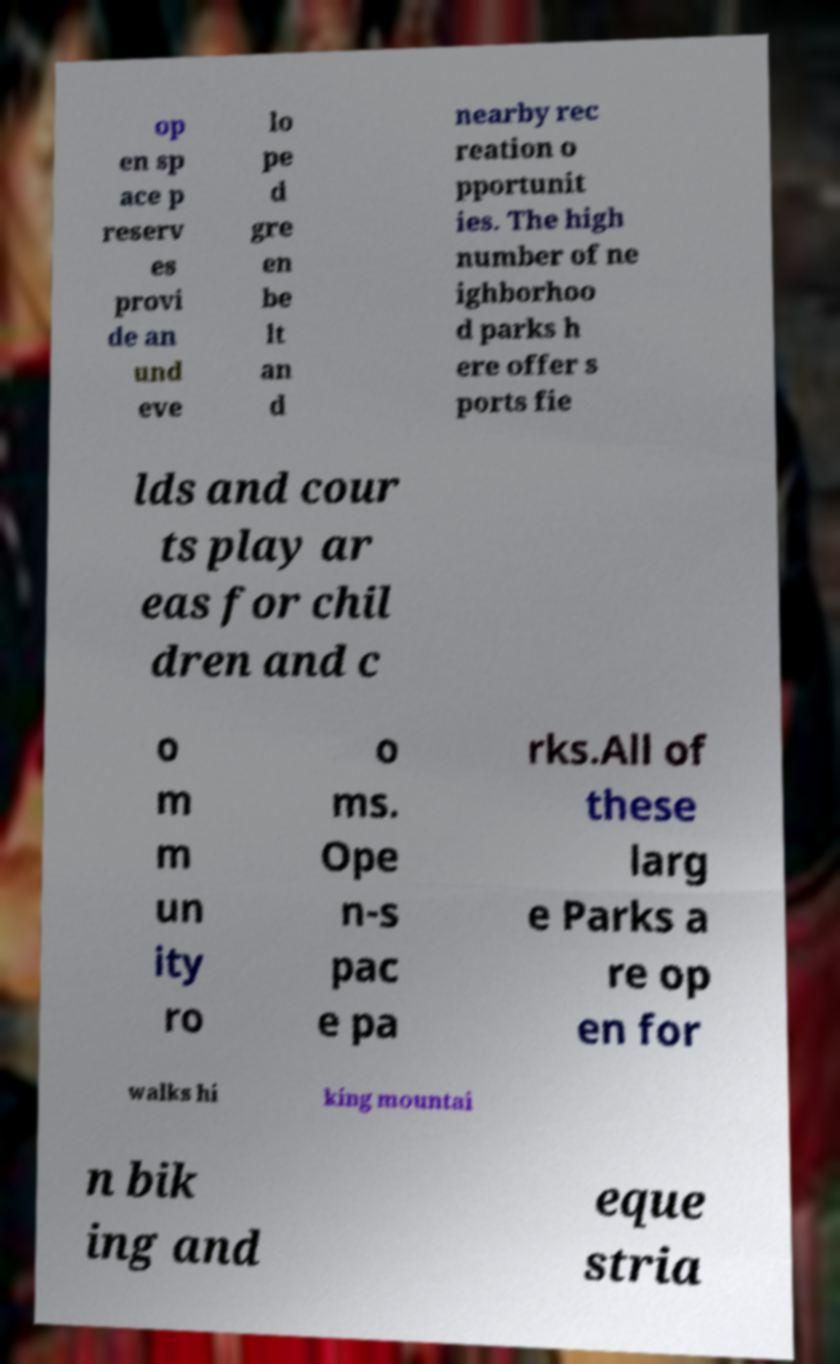Please read and relay the text visible in this image. What does it say? op en sp ace p reserv es provi de an und eve lo pe d gre en be lt an d nearby rec reation o pportunit ies. The high number of ne ighborhoo d parks h ere offer s ports fie lds and cour ts play ar eas for chil dren and c o m m un ity ro o ms. Ope n-s pac e pa rks.All of these larg e Parks a re op en for walks hi king mountai n bik ing and eque stria 